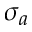<formula> <loc_0><loc_0><loc_500><loc_500>\sigma _ { a }</formula> 